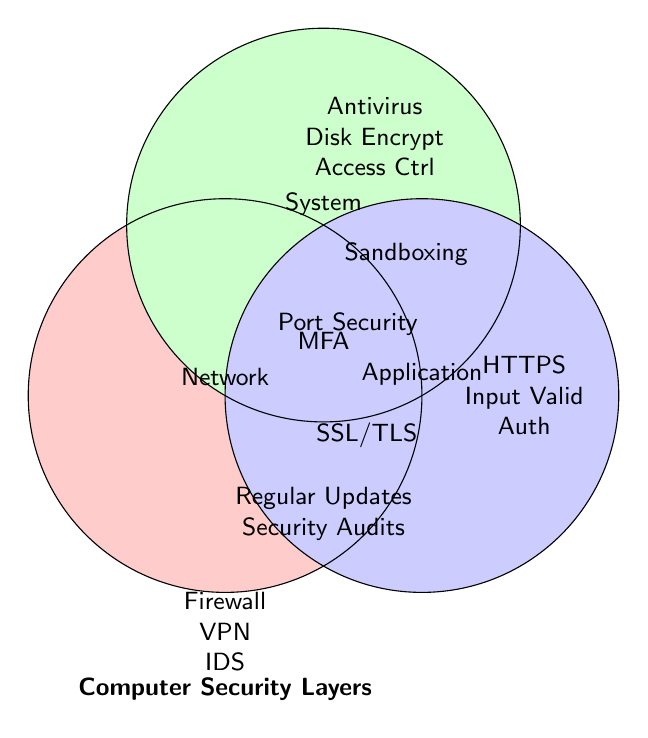What are the categories represented in the Venn Diagram? The Venn Diagram consists of three labeled sections representing different categories, which are Network, System, and Application.
Answer: Network, System, Application Which item is common to all three categories? Multi-Factor Authentication is placed where all three circles intersect, indicating that it is common to Network, System, and Application categories.
Answer: Multi-Factor Authentication What items are only in the Network category? The items listed in the Network section, which do not overlap with any other circles, are Firewall, VPN, and Intrusion Detection System.
Answer: Firewall, VPN, Intrusion Detection System Which item belongs to both Network and Application categories but not System? SSL/TLS is positioned in the overlapping area of the Network and Application circles, but outside of the System circle.
Answer: SSL/TLS How many items belong to both System and Application categories? There is one item that lies in the intersection of the System and Application circles, which is Sandboxing.
Answer: 1 How many items in total are shared between two or more categories? There are five items in the overlapping sections: Port Security, SSL/TLS, Sandboxing, Multi-Factor Authentication, Regular Updates, and Security Audits.
Answer: 5 Which items belong to the central section of the Venn Diagram? The central section includes all items that are common to all three categories. For this Venn Diagram, these items are Regular Updates and Security Audits.
Answer: Regular Updates, Security Audits Is there any item that belongs to both Network and System categories but not Application? Yes, Port Security is positioned in the overlapping area of the Network and System circles, but outside the Application circle.
Answer: Port Security 